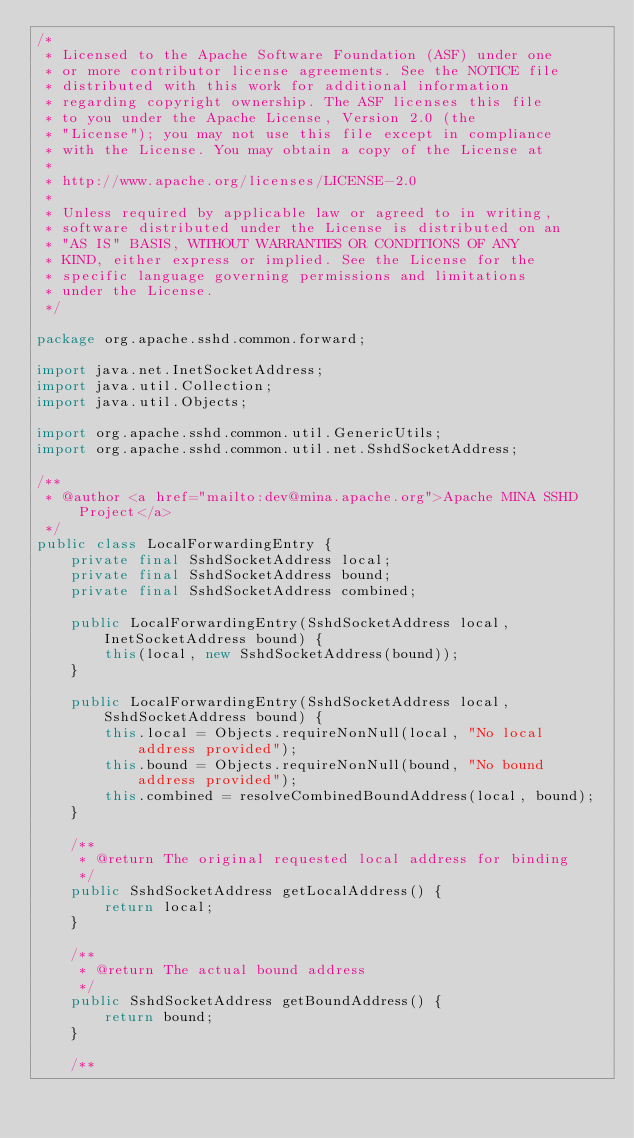<code> <loc_0><loc_0><loc_500><loc_500><_Java_>/*
 * Licensed to the Apache Software Foundation (ASF) under one
 * or more contributor license agreements. See the NOTICE file
 * distributed with this work for additional information
 * regarding copyright ownership. The ASF licenses this file
 * to you under the Apache License, Version 2.0 (the
 * "License"); you may not use this file except in compliance
 * with the License. You may obtain a copy of the License at
 *
 * http://www.apache.org/licenses/LICENSE-2.0
 *
 * Unless required by applicable law or agreed to in writing,
 * software distributed under the License is distributed on an
 * "AS IS" BASIS, WITHOUT WARRANTIES OR CONDITIONS OF ANY
 * KIND, either express or implied. See the License for the
 * specific language governing permissions and limitations
 * under the License.
 */

package org.apache.sshd.common.forward;

import java.net.InetSocketAddress;
import java.util.Collection;
import java.util.Objects;

import org.apache.sshd.common.util.GenericUtils;
import org.apache.sshd.common.util.net.SshdSocketAddress;

/**
 * @author <a href="mailto:dev@mina.apache.org">Apache MINA SSHD Project</a>
 */
public class LocalForwardingEntry {
    private final SshdSocketAddress local;
    private final SshdSocketAddress bound;
    private final SshdSocketAddress combined;

    public LocalForwardingEntry(SshdSocketAddress local, InetSocketAddress bound) {
        this(local, new SshdSocketAddress(bound));
    }

    public LocalForwardingEntry(SshdSocketAddress local, SshdSocketAddress bound) {
        this.local = Objects.requireNonNull(local, "No local address provided");
        this.bound = Objects.requireNonNull(bound, "No bound address provided");
        this.combined = resolveCombinedBoundAddress(local, bound);
    }

    /**
     * @return The original requested local address for binding
     */
    public SshdSocketAddress getLocalAddress() {
        return local;
    }

    /**
     * @return The actual bound address
     */
    public SshdSocketAddress getBoundAddress() {
        return bound;
    }

    /**</code> 